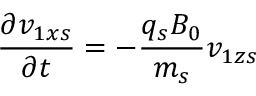<formula> <loc_0><loc_0><loc_500><loc_500>\frac { \partial { v } _ { 1 x s } } { \partial t } = - \frac { q _ { s } B _ { 0 } } { m _ { s } } { v } _ { 1 z s }</formula> 